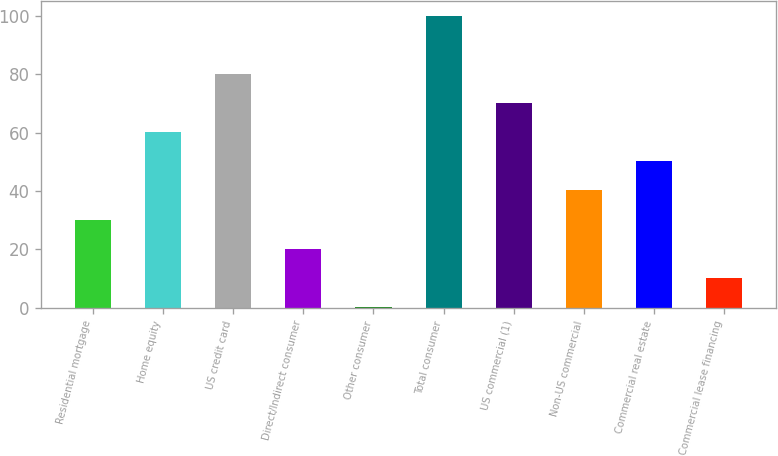<chart> <loc_0><loc_0><loc_500><loc_500><bar_chart><fcel>Residential mortgage<fcel>Home equity<fcel>US credit card<fcel>Direct/Indirect consumer<fcel>Other consumer<fcel>Total consumer<fcel>US commercial (1)<fcel>Non-US commercial<fcel>Commercial real estate<fcel>Commercial lease financing<nl><fcel>30.23<fcel>60.14<fcel>80.08<fcel>20.26<fcel>0.32<fcel>100.02<fcel>70.11<fcel>40.2<fcel>50.17<fcel>10.29<nl></chart> 